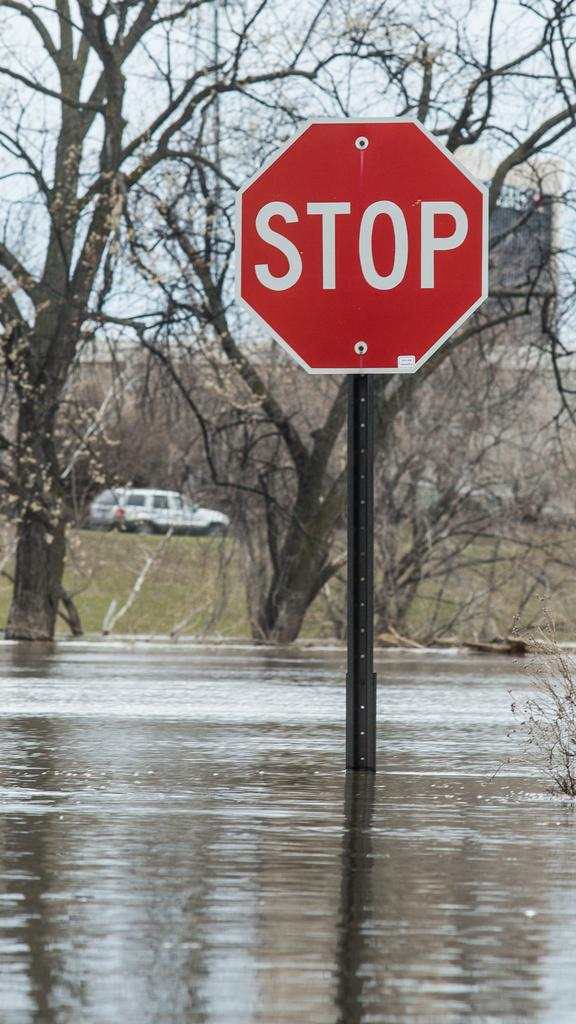<image>
Present a compact description of the photo's key features. A severely flooded area with a STOP sign sticking up out of the water 